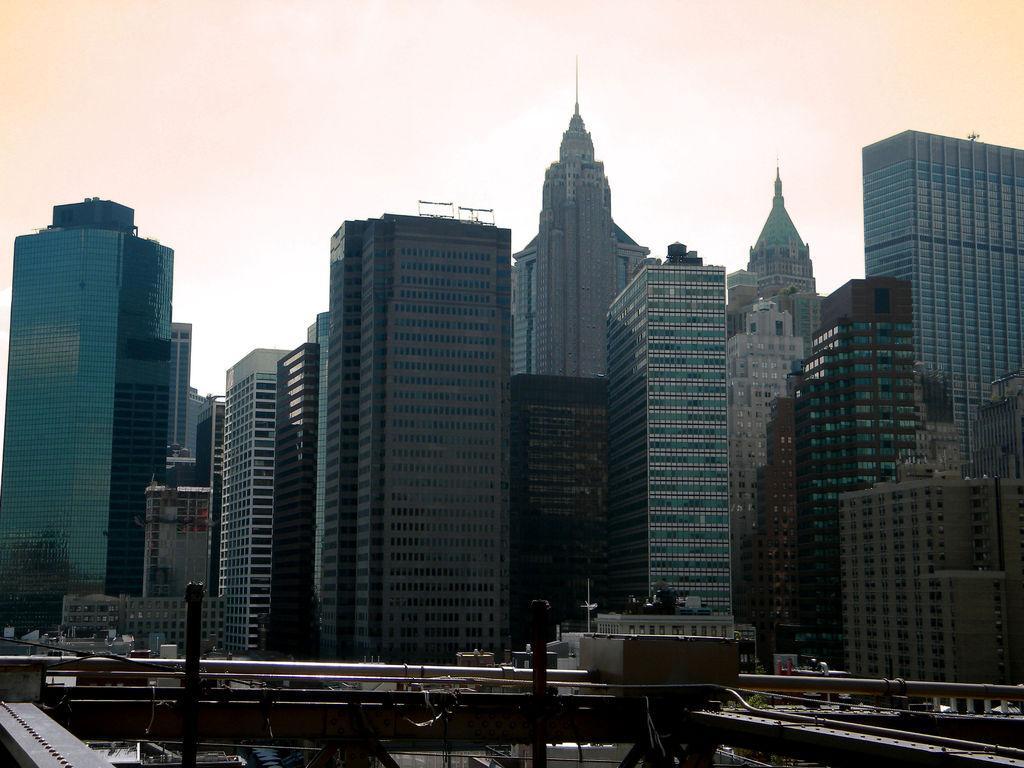Could you give a brief overview of what you see in this image? In the middle of the image there are some buildings. Behind the buildings there are some clouds and sky. Bottom of the image there is fencing. 